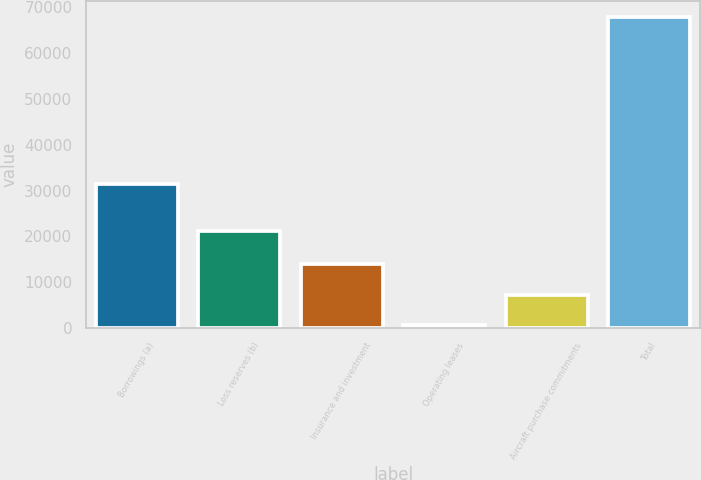Convert chart to OTSL. <chart><loc_0><loc_0><loc_500><loc_500><bar_chart><fcel>Borrowings (a)<fcel>Loss reserves (b)<fcel>Insurance and investment<fcel>Operating leases<fcel>Aircraft purchase commitments<fcel>Total<nl><fcel>31504<fcel>21221<fcel>14053.2<fcel>573<fcel>7313.1<fcel>67974<nl></chart> 